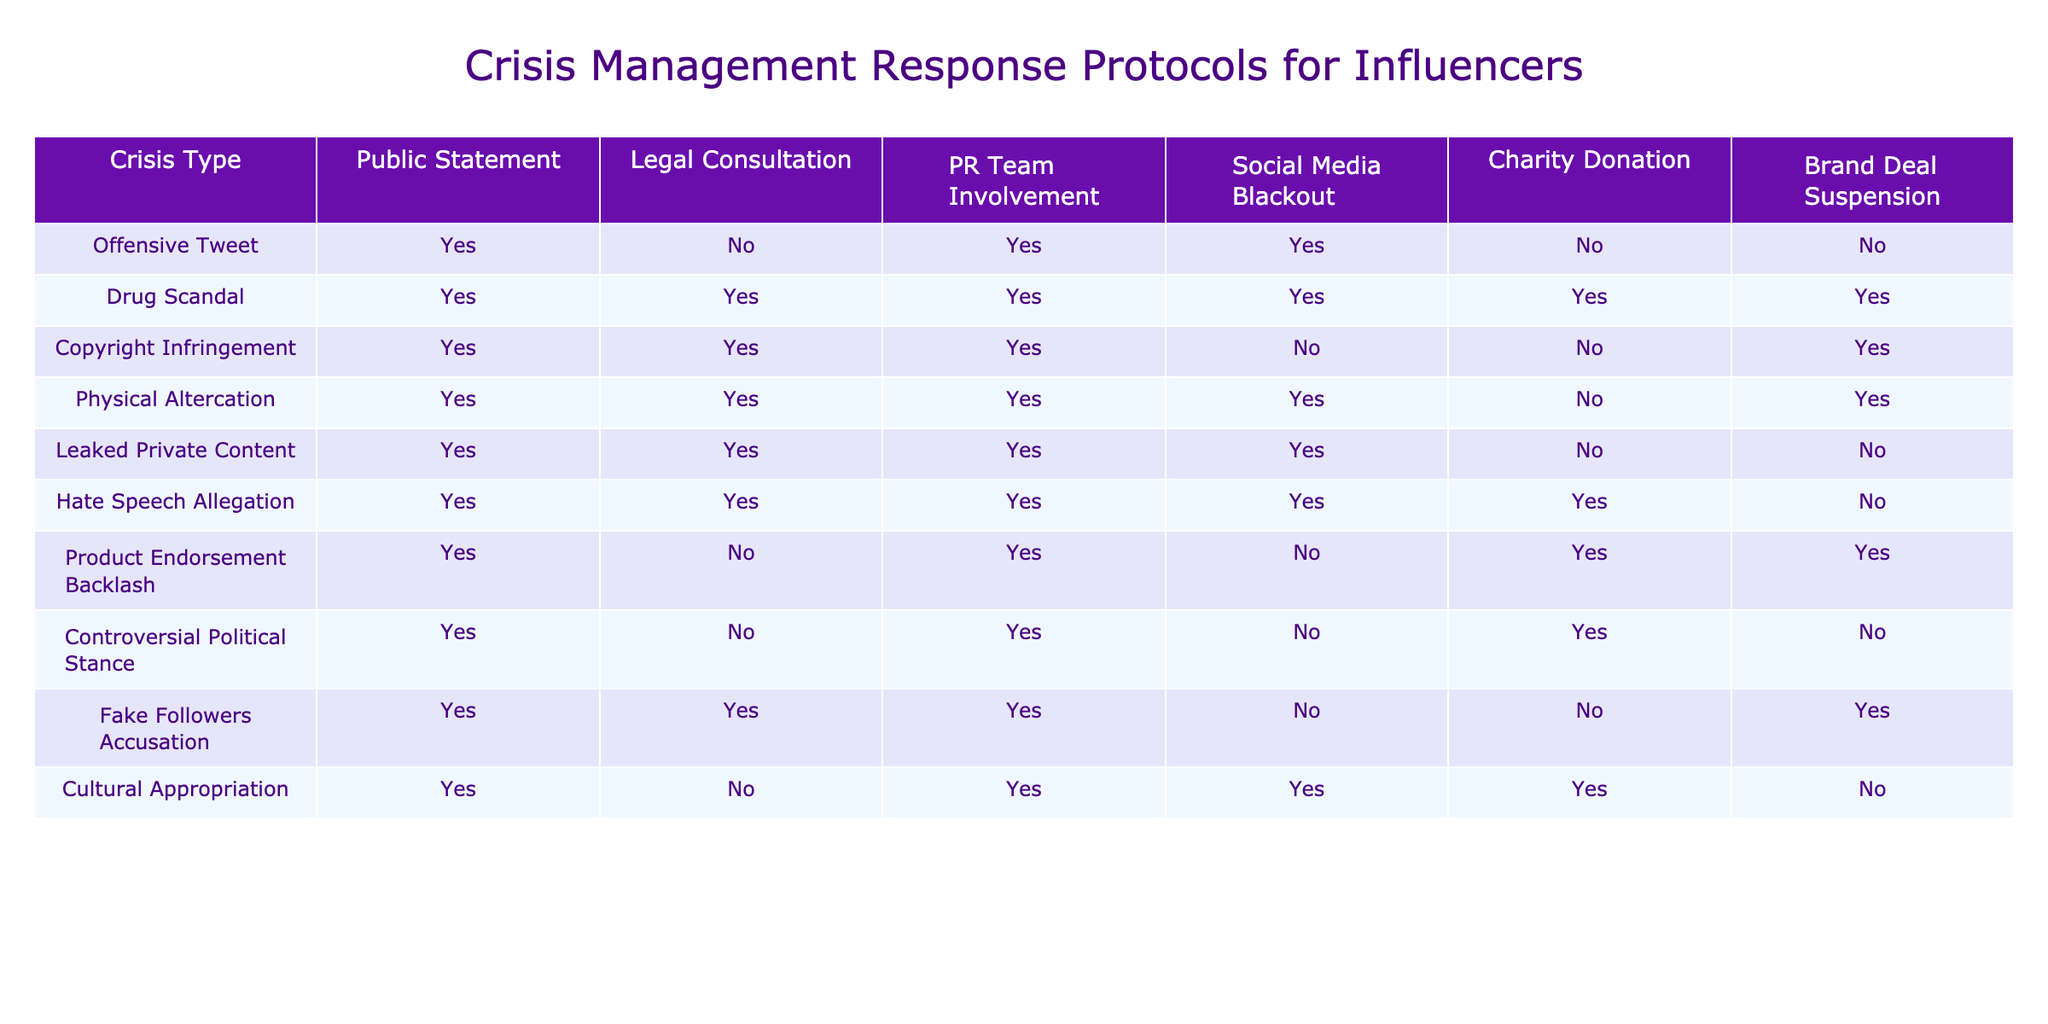What crisis type involves social media blackout but not legal consultation? By examining the table, the only crisis type that shows a social media blackout (Yes) while not involving legal consultation (No) is "Product Endorsement Backlash."
Answer: Product Endorsement Backlash How many crisis types require charity donations? To find the number of crisis types requiring charity donations, we tally the "Yes" entries in the "Charity Donation" column. The entries are for Drug Scandal, Physical Altercation, Product Endorsement Backlash, Cultural Appropriation, totaling 4 crisis types.
Answer: 4 Is a public statement always required for a leaked private content crisis? Referring to the table, a public statement is indicated as "Yes" for Leaked Private Content. Therefore, it does require a public statement.
Answer: Yes Which crisis type has the highest number of "Yes" responses across the columns? To find the crisis type with the highest number of "Yes" responses, we count the 'Yes' for each row: Drug Scandal (6), Physical Altercation (5), and others with fewer. Drug Scandal has the maximum count at 6 "Yes" responses.
Answer: Drug Scandal Do any crisis types involve both a charity donation and a social media blackout? By checking the table, we see that Drug Scandal involves both a charity donation and a social media blackout. Therefore, it is indeed a crisis type that meets both criteria.
Answer: Yes In how many crisis types is brand deal suspension not applied? We examine the "Brand Deal Suspension" column for "No" entries. The entries for Offensive Tweet, Drug Scandal, and Hate Speech Allegation indicate that none of them require suspension. Therefore, the total number is 3.
Answer: 3 Are legal consultations needed for all types of drug scandals? The table indicates that legal consultation is indeed required for the "Drug Scandal" crisis type, confirming that legal consultation is essential in this case.
Answer: Yes Which types of crises require multi-faceted responses (more than three "Yes" responses)? Analyzing each type, Drug Scandal has 6 "Yes" responses, Physical Altercation has 5, Fake Followers Accusation has 4, and Hate Speech Allegation has 5. Therefore, the types that require complex responses are Drug Scandal, Physical Altercation, Fake Followers Accusation, and Hate Speech Allegation.
Answer: Drug Scandal, Physical Altercation, Fake Followers Accusation, Hate Speech Allegation 